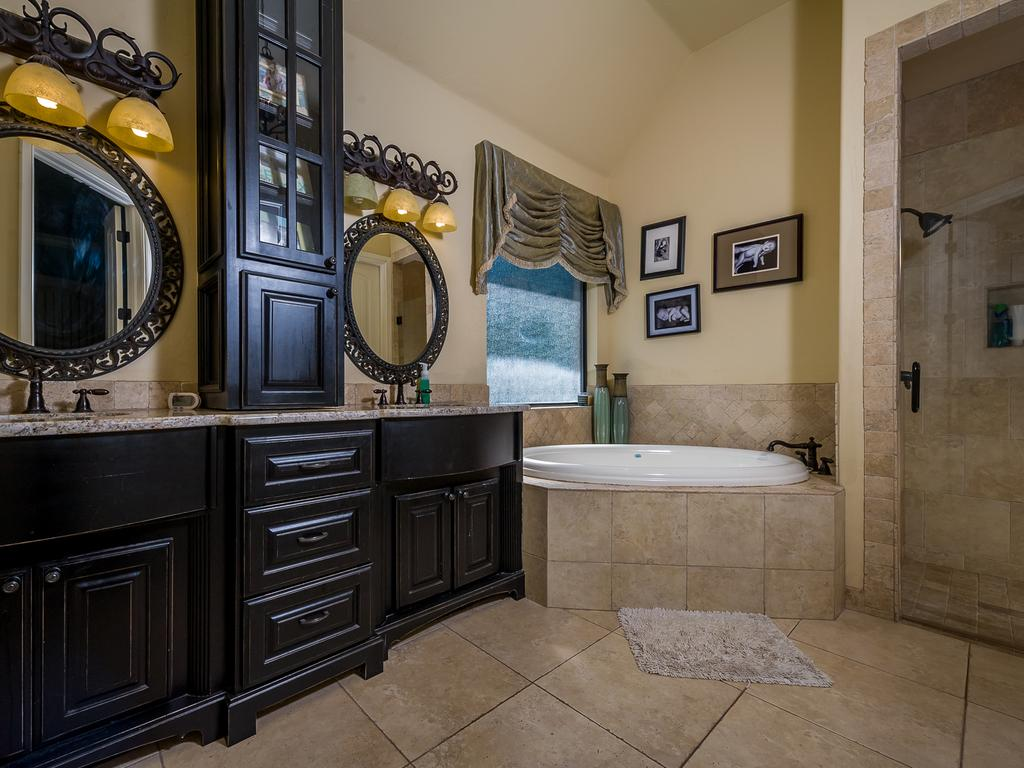What type of reflective surfaces can be seen in the image? There are mirrors in the image. What can be used for washing hands or cleaning in the image? There are sinks and taps in the image. What is the purpose of the bottle in the image? The purpose of the bottle in the image is not clear, but it is present. What type of storage is available in the image? There are cupboards in the image. What objects are placed on a table in the image? There are objects on a table in the image, but their specific nature is not mentioned. What type of bathing facility is present in the image? There is a bathtub and a shower in the image. What can be seen near the window in the image? There is a curtain associated with the window in the image. What type of wall is present in the image? The wall is described as cream-colored. Can you hear a whistle in the image? There is no mention of a whistle in the image. What type of hall is present in the image? The provided facts do not mention a hall in the image. 